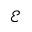Convert formula to latex. <formula><loc_0><loc_0><loc_500><loc_500>\mathcal { E }</formula> 